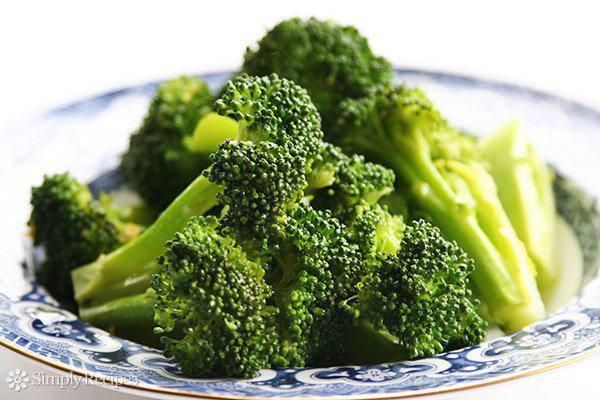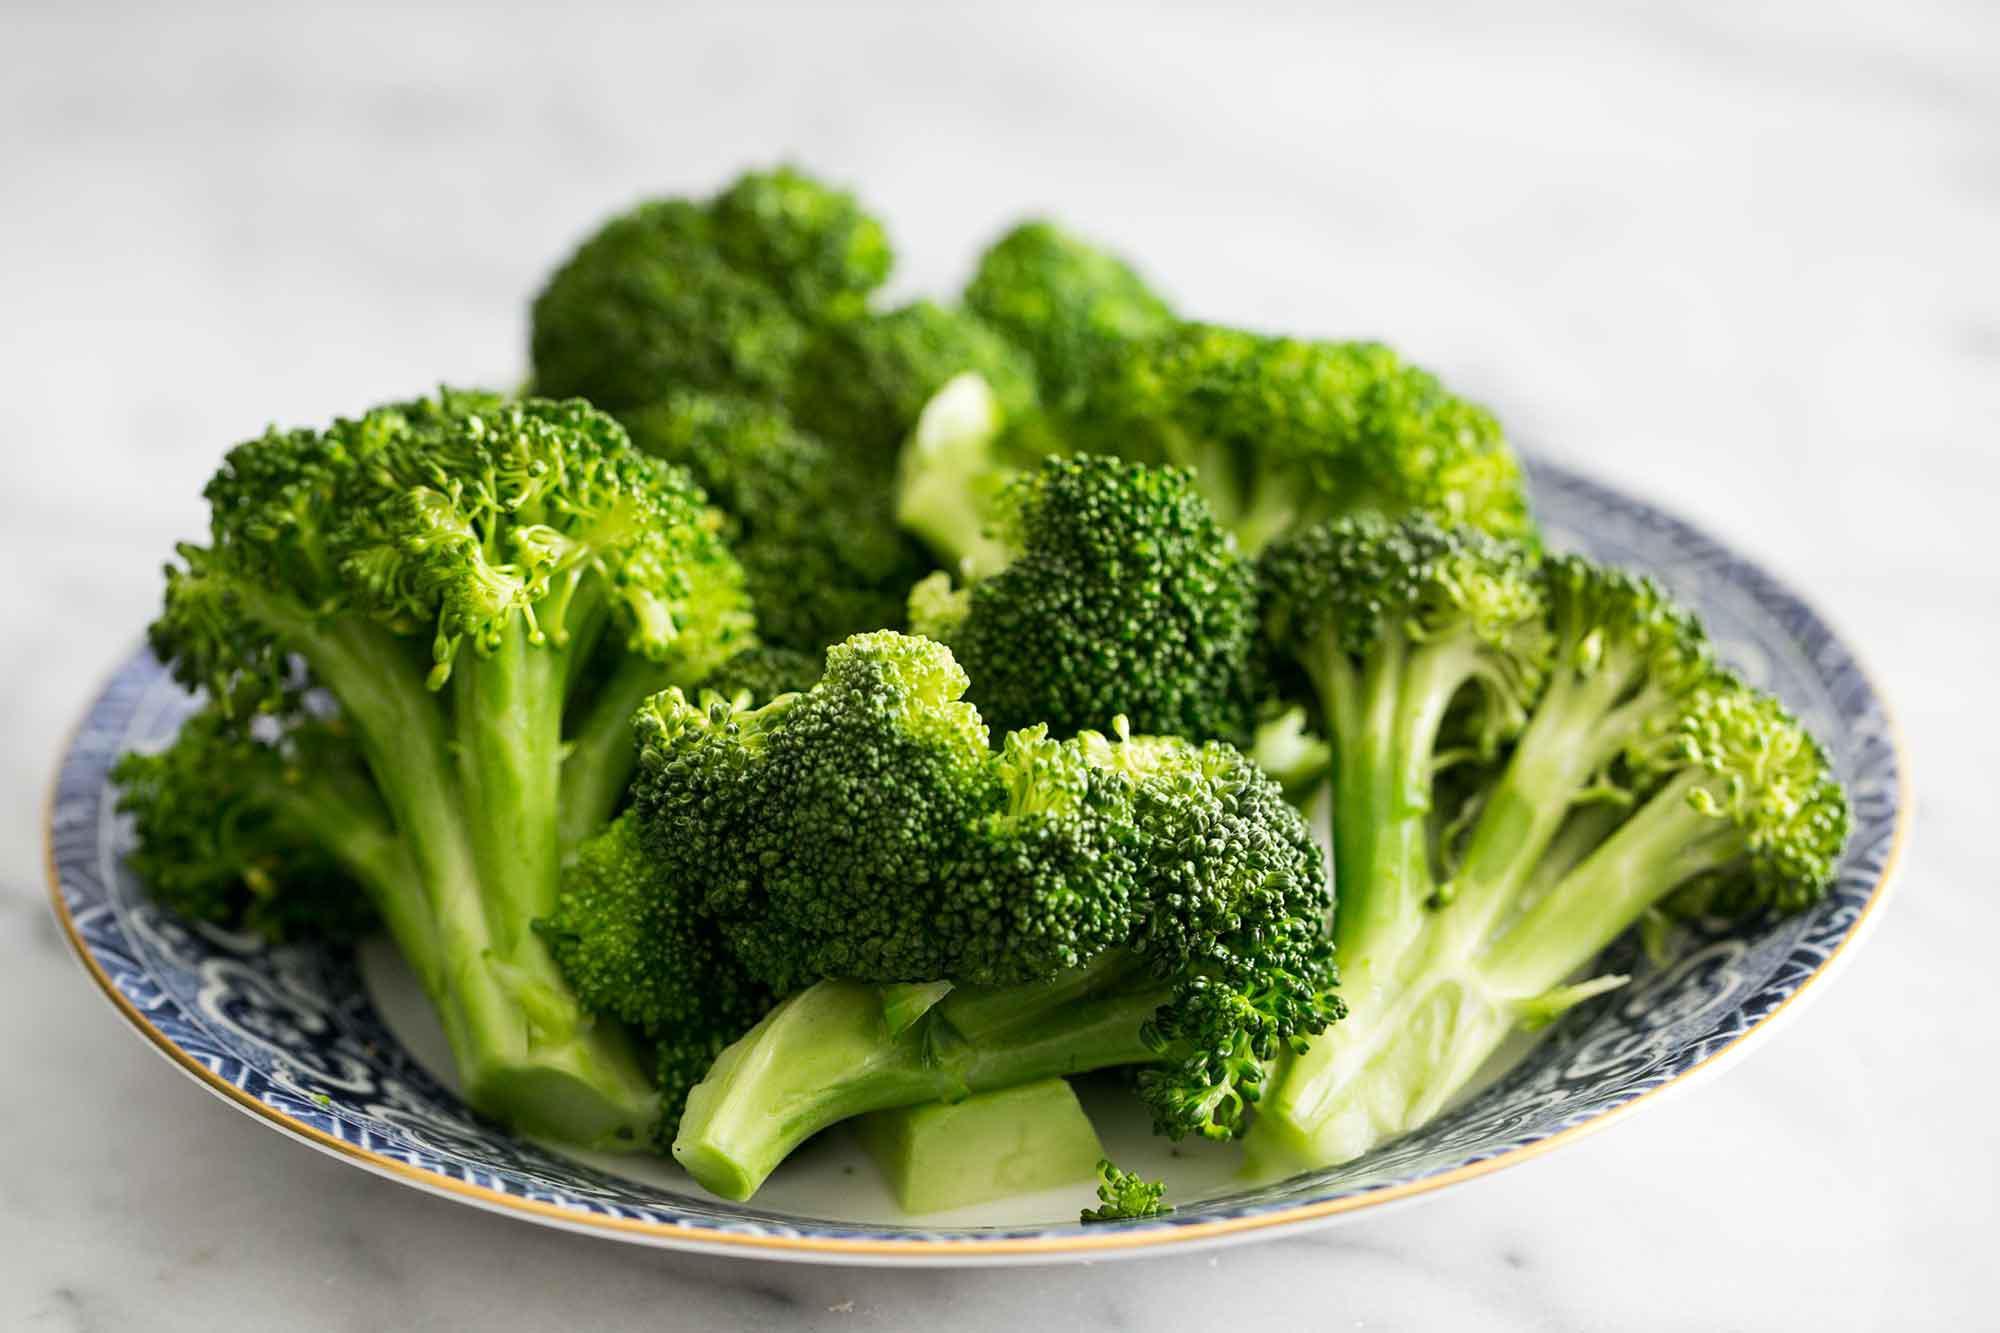The first image is the image on the left, the second image is the image on the right. For the images shown, is this caption "The left and right image contains the same number of porcelain plates holding broccoli." true? Answer yes or no. Yes. 